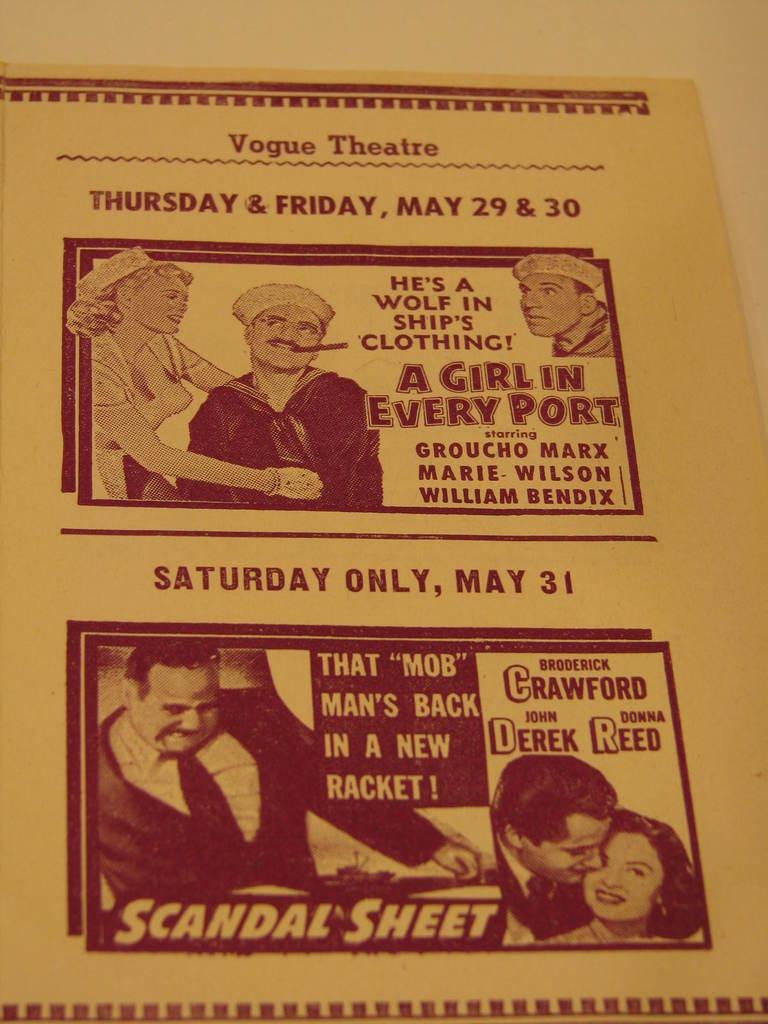What is the main object in the picture? There is a pamphlet in the picture. What can be found on the pamphlet? The pamphlet contains pictures of a group of people and text. What is the color of the background on the pamphlet? The background of the pamphlet is cream-colored. Is there a quill used for writing on the pamphlet? There is no quill visible in the image, and it is not mentioned in the provided facts. 